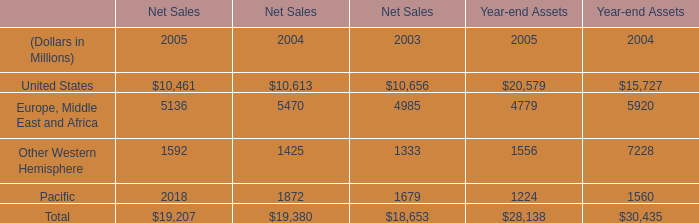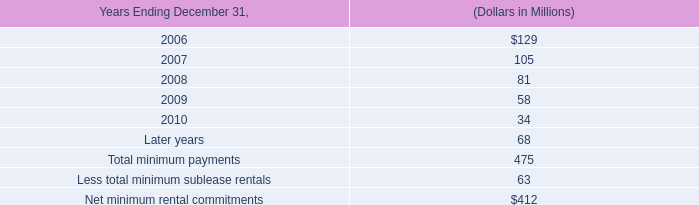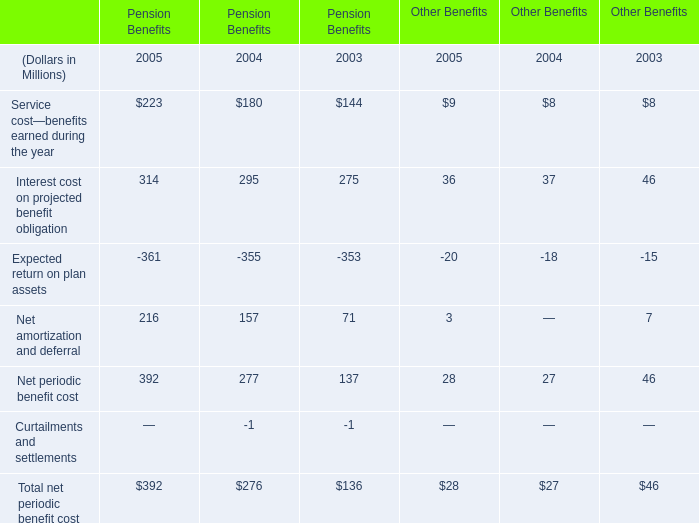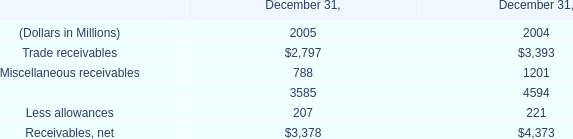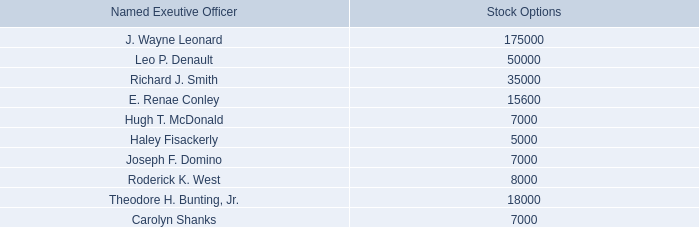What's the growth rate of United States in Net Sales in 2005? 
Computations: ((10461 - 10613) / 10613)
Answer: -0.01432. 